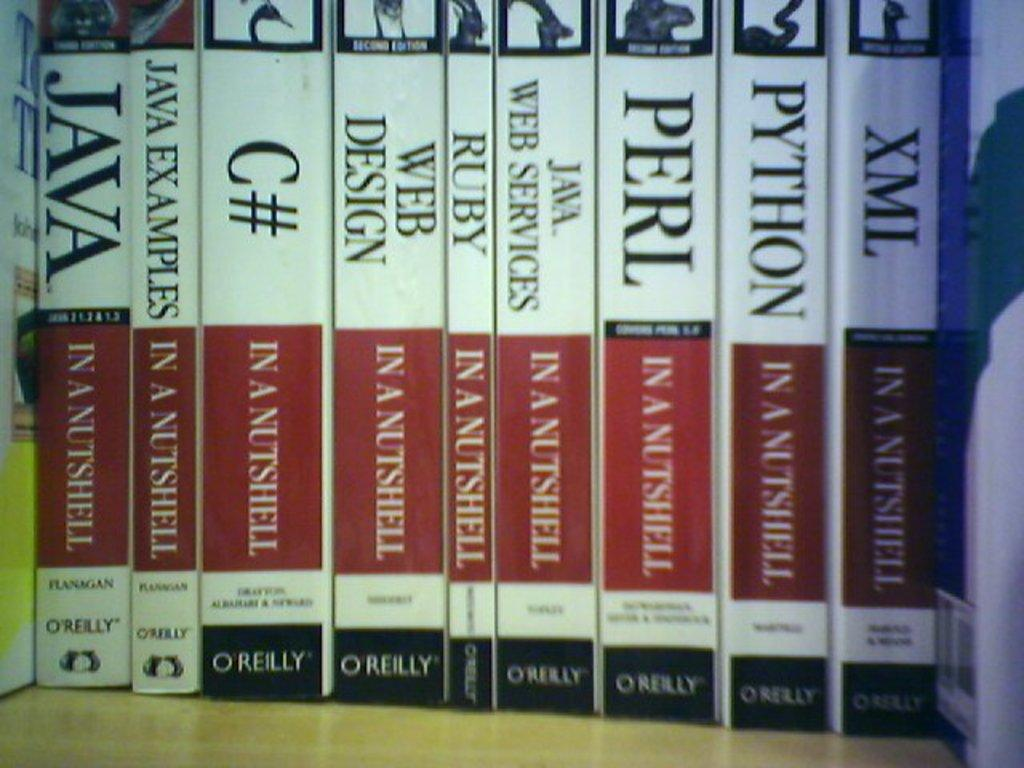What type of items can be seen in the image? There are many books in the image. What subject matter do the books cover? The books are related to computer languages. What colors are present on the book covers? The books have white and red colors. What type of hat is the truck wearing in the image? There is no truck or hat present in the image; it features many books related to computer languages with white and red colors on their covers. 